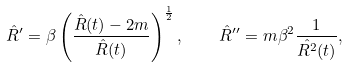Convert formula to latex. <formula><loc_0><loc_0><loc_500><loc_500>\hat { R } ^ { \prime } = \beta \left ( \frac { \hat { R } ( t ) - 2 m } { \hat { R } ( t ) } \right ) ^ { \frac { 1 } { 2 } } , \quad \hat { R } ^ { \prime \prime } = m \beta ^ { 2 } \frac { 1 } { \hat { R ^ { 2 } } ( t ) } ,</formula> 